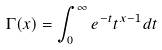<formula> <loc_0><loc_0><loc_500><loc_500>\Gamma ( x ) = \int _ { 0 } ^ { \infty } e ^ { - t } t ^ { x - 1 } d t</formula> 